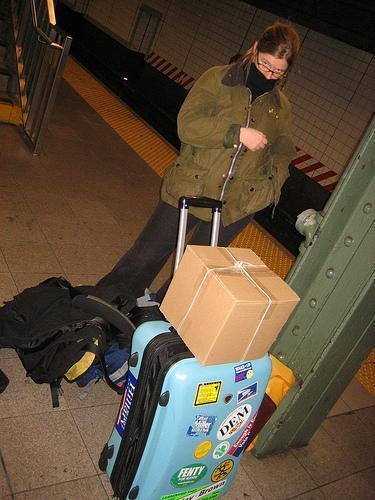How many bags and boxes does the person have?
Give a very brief answer. 5. How many round stickers are on the suitcase?
Give a very brief answer. 4. 